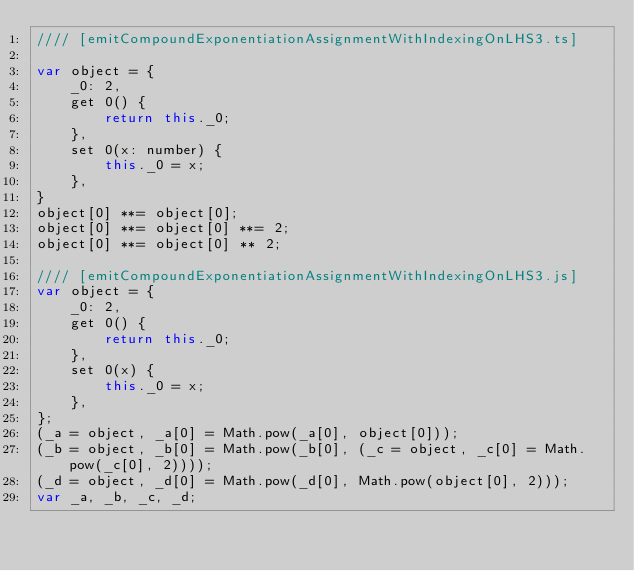<code> <loc_0><loc_0><loc_500><loc_500><_JavaScript_>//// [emitCompoundExponentiationAssignmentWithIndexingOnLHS3.ts]

var object = {
    _0: 2,
    get 0() {
        return this._0;
    },
    set 0(x: number) {
        this._0 = x;
    },
}
object[0] **= object[0];
object[0] **= object[0] **= 2;
object[0] **= object[0] ** 2;

//// [emitCompoundExponentiationAssignmentWithIndexingOnLHS3.js]
var object = {
    _0: 2,
    get 0() {
        return this._0;
    },
    set 0(x) {
        this._0 = x;
    },
};
(_a = object, _a[0] = Math.pow(_a[0], object[0]));
(_b = object, _b[0] = Math.pow(_b[0], (_c = object, _c[0] = Math.pow(_c[0], 2))));
(_d = object, _d[0] = Math.pow(_d[0], Math.pow(object[0], 2)));
var _a, _b, _c, _d;
</code> 